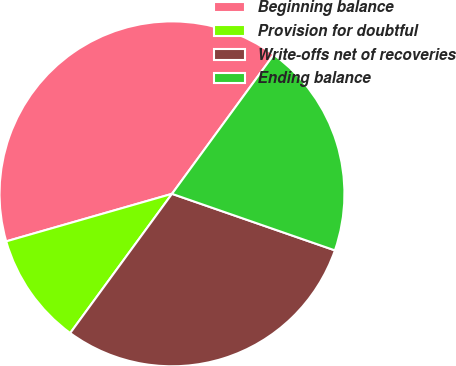Convert chart to OTSL. <chart><loc_0><loc_0><loc_500><loc_500><pie_chart><fcel>Beginning balance<fcel>Provision for doubtful<fcel>Write-offs net of recoveries<fcel>Ending balance<nl><fcel>39.49%<fcel>10.51%<fcel>29.73%<fcel>20.27%<nl></chart> 